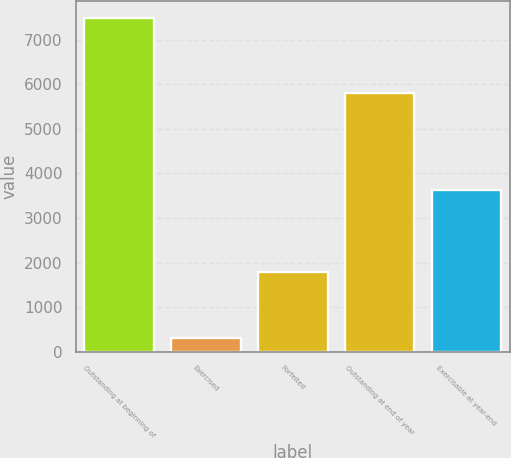Convert chart to OTSL. <chart><loc_0><loc_0><loc_500><loc_500><bar_chart><fcel>Outstanding at beginning of<fcel>Exercised<fcel>Forfeited<fcel>Outstanding at end of year<fcel>Exercisable at year-end<nl><fcel>7495<fcel>306<fcel>1784<fcel>5802<fcel>3627<nl></chart> 